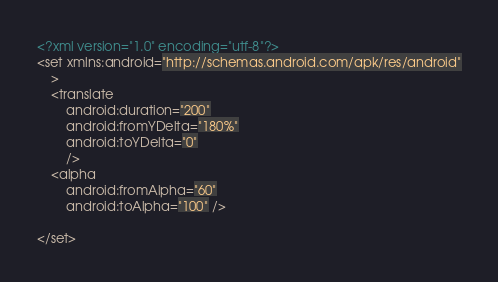<code> <loc_0><loc_0><loc_500><loc_500><_XML_><?xml version="1.0" encoding="utf-8"?>
<set xmlns:android="http://schemas.android.com/apk/res/android"
    >
    <translate
        android:duration="200"
        android:fromYDelta="180%"
        android:toYDelta="0"
        />
    <alpha
        android:fromAlpha="60"
        android:toAlpha="100" />

</set></code> 